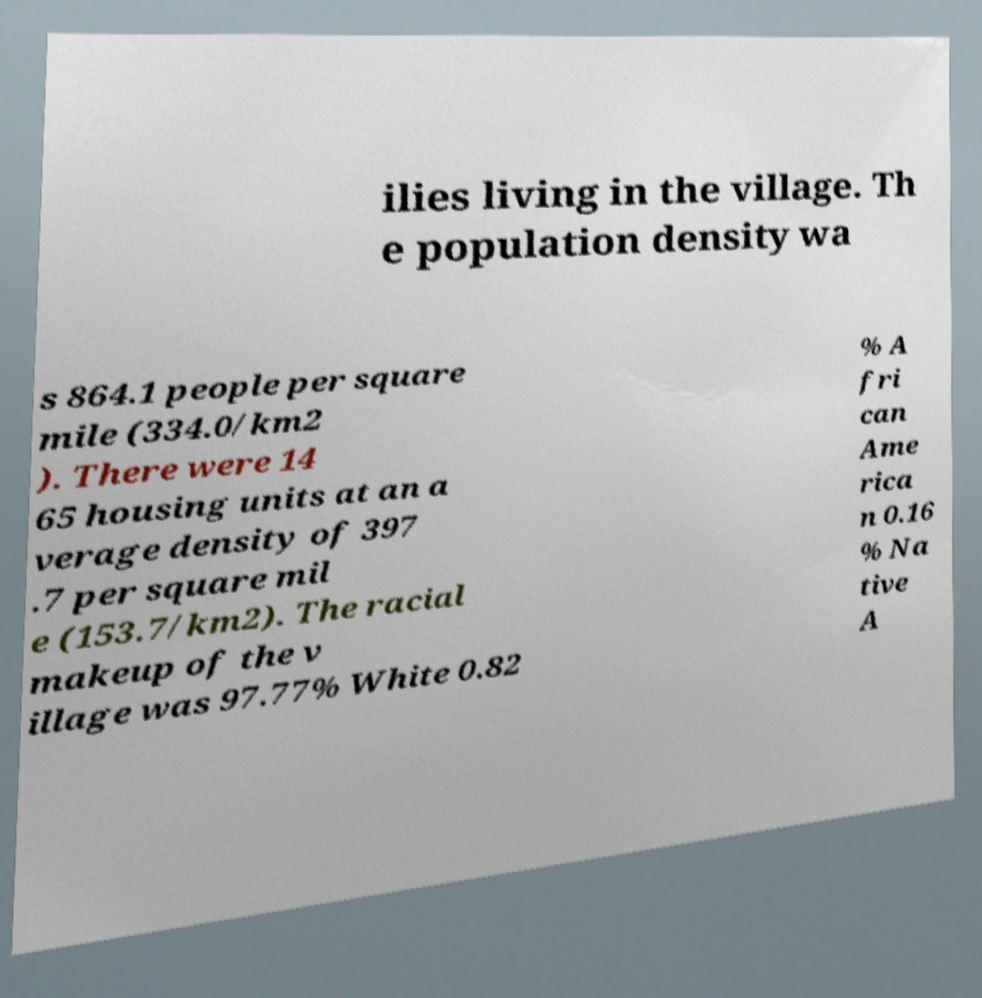What messages or text are displayed in this image? I need them in a readable, typed format. ilies living in the village. Th e population density wa s 864.1 people per square mile (334.0/km2 ). There were 14 65 housing units at an a verage density of 397 .7 per square mil e (153.7/km2). The racial makeup of the v illage was 97.77% White 0.82 % A fri can Ame rica n 0.16 % Na tive A 